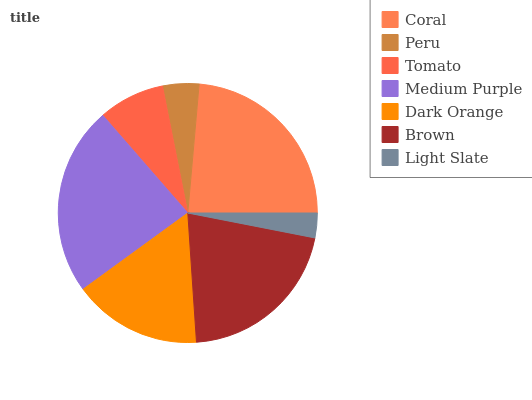Is Light Slate the minimum?
Answer yes or no. Yes. Is Medium Purple the maximum?
Answer yes or no. Yes. Is Peru the minimum?
Answer yes or no. No. Is Peru the maximum?
Answer yes or no. No. Is Coral greater than Peru?
Answer yes or no. Yes. Is Peru less than Coral?
Answer yes or no. Yes. Is Peru greater than Coral?
Answer yes or no. No. Is Coral less than Peru?
Answer yes or no. No. Is Dark Orange the high median?
Answer yes or no. Yes. Is Dark Orange the low median?
Answer yes or no. Yes. Is Tomato the high median?
Answer yes or no. No. Is Coral the low median?
Answer yes or no. No. 